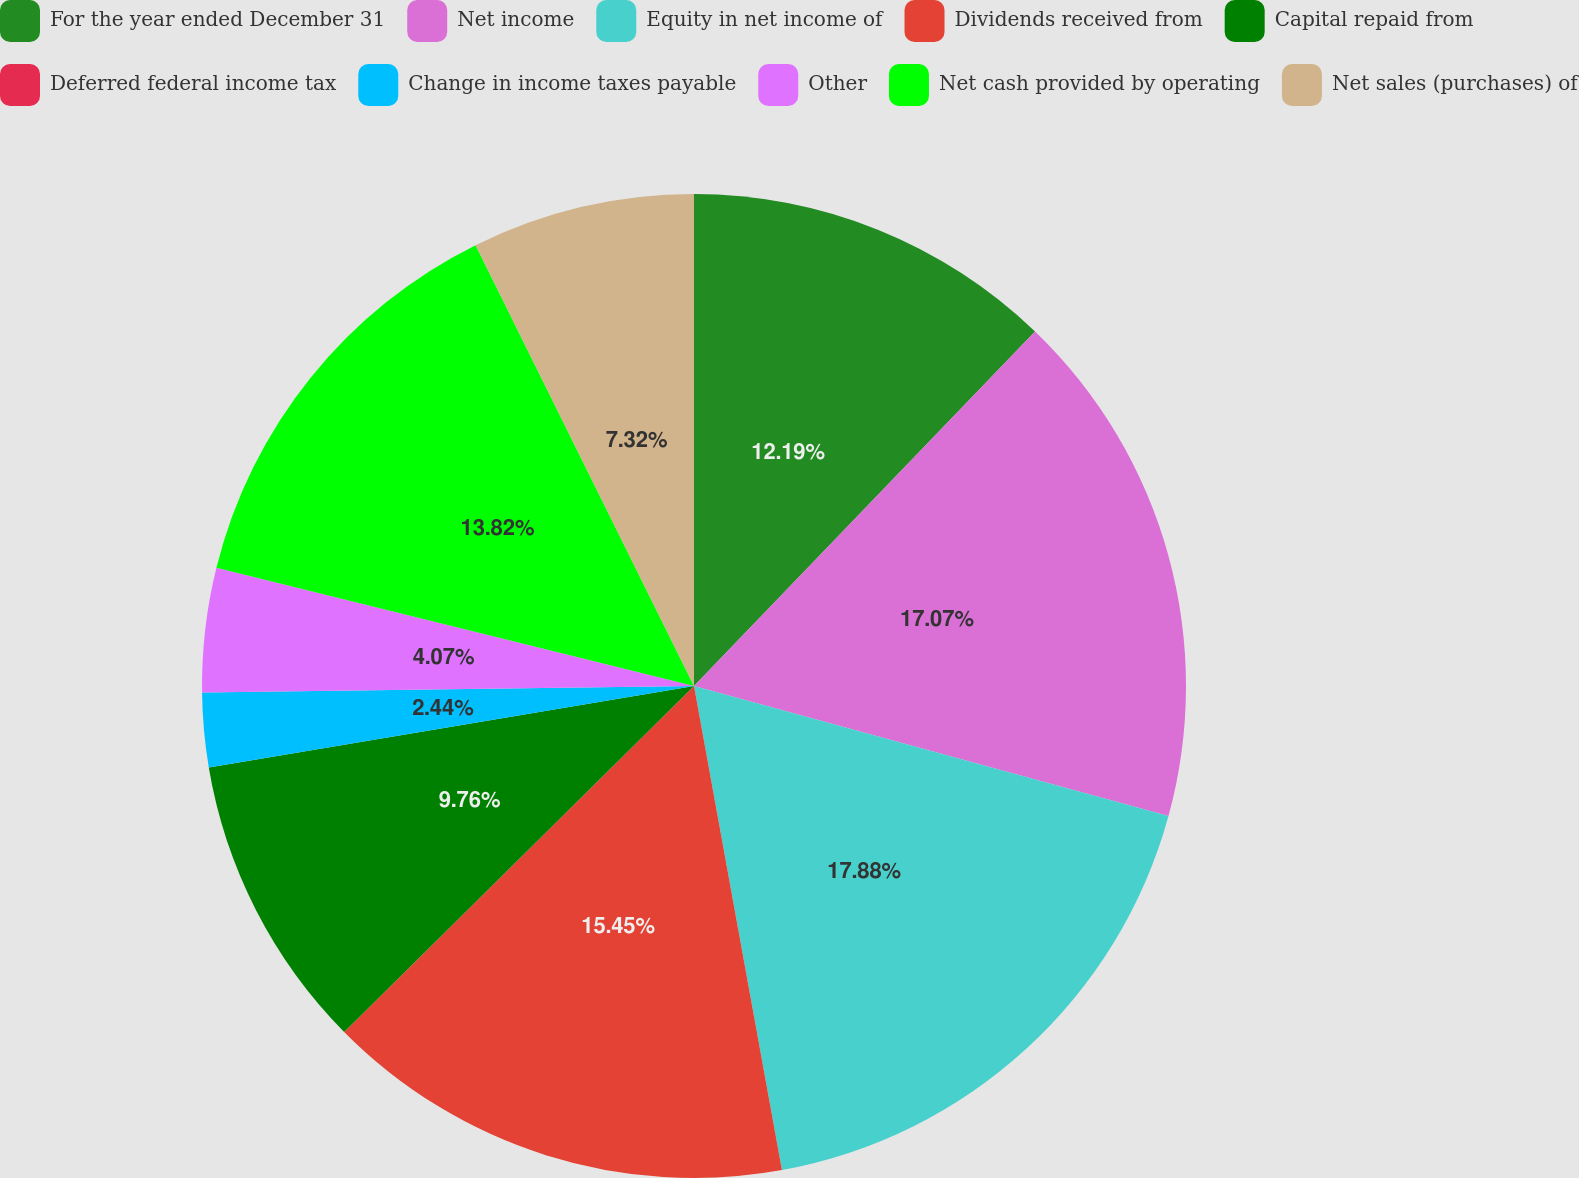Convert chart to OTSL. <chart><loc_0><loc_0><loc_500><loc_500><pie_chart><fcel>For the year ended December 31<fcel>Net income<fcel>Equity in net income of<fcel>Dividends received from<fcel>Capital repaid from<fcel>Deferred federal income tax<fcel>Change in income taxes payable<fcel>Other<fcel>Net cash provided by operating<fcel>Net sales (purchases) of<nl><fcel>12.19%<fcel>17.07%<fcel>17.88%<fcel>15.45%<fcel>9.76%<fcel>0.0%<fcel>2.44%<fcel>4.07%<fcel>13.82%<fcel>7.32%<nl></chart> 